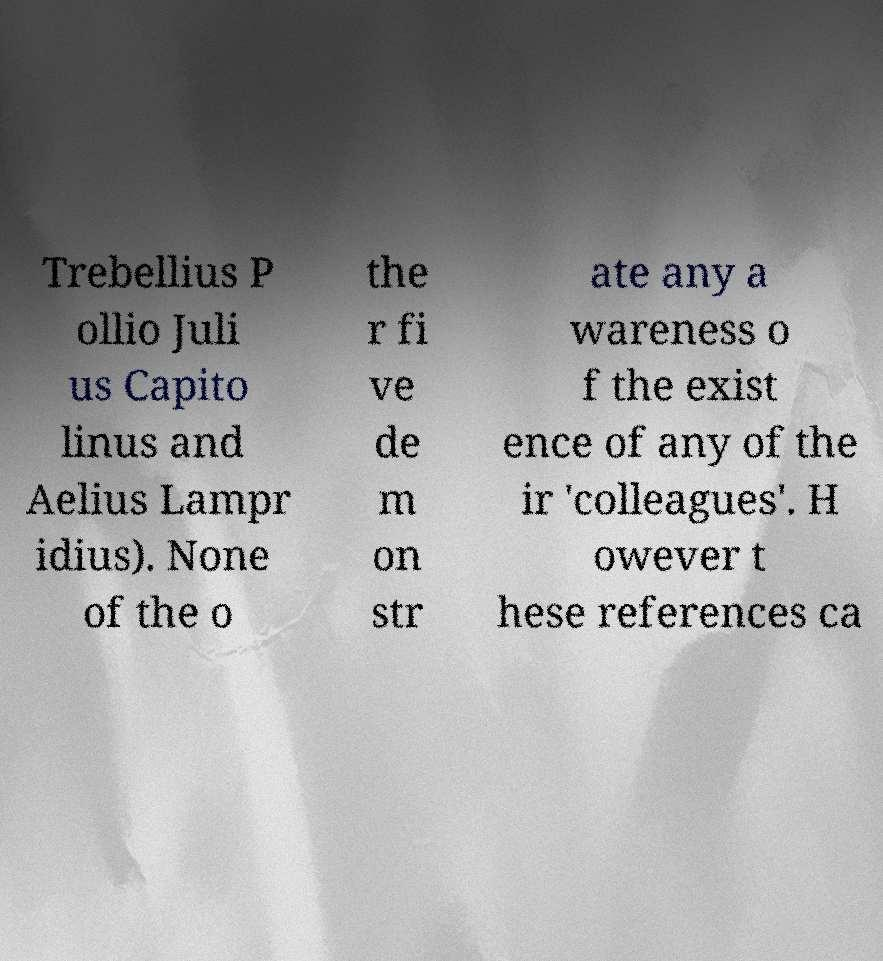Please read and relay the text visible in this image. What does it say? Trebellius P ollio Juli us Capito linus and Aelius Lampr idius). None of the o the r fi ve de m on str ate any a wareness o f the exist ence of any of the ir 'colleagues'. H owever t hese references ca 